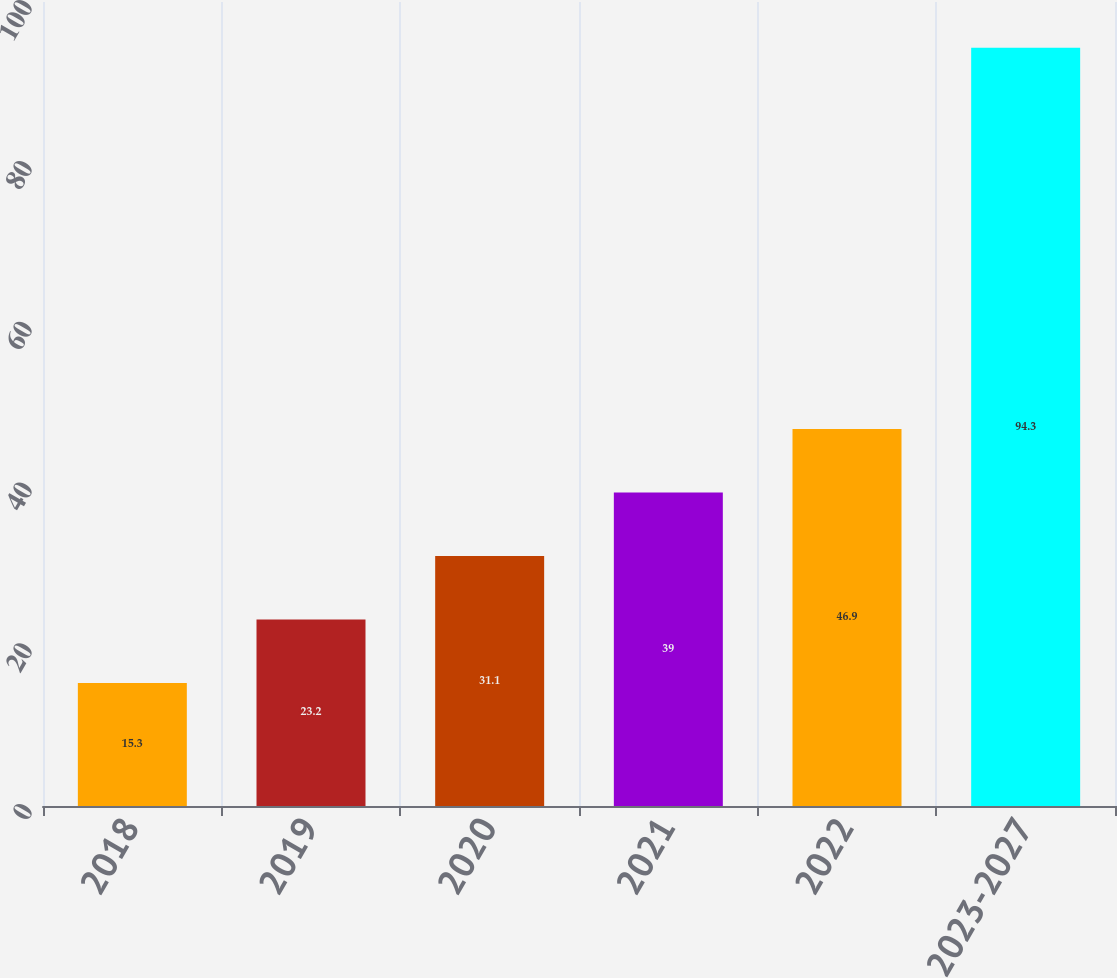Convert chart. <chart><loc_0><loc_0><loc_500><loc_500><bar_chart><fcel>2018<fcel>2019<fcel>2020<fcel>2021<fcel>2022<fcel>2023-2027<nl><fcel>15.3<fcel>23.2<fcel>31.1<fcel>39<fcel>46.9<fcel>94.3<nl></chart> 